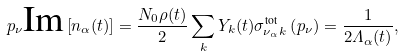Convert formula to latex. <formula><loc_0><loc_0><loc_500><loc_500>p _ { \nu } \text {Im} \left [ n _ { \alpha } ( t ) \right ] = \frac { N _ { 0 } \rho ( t ) } { 2 } \sum _ { k } Y _ { k } ( t ) \sigma _ { \nu _ { \alpha } k } ^ { \text {tot} } \left ( p _ { \nu } \right ) = \frac { 1 } { 2 \varLambda _ { \alpha } ( t ) } ,</formula> 